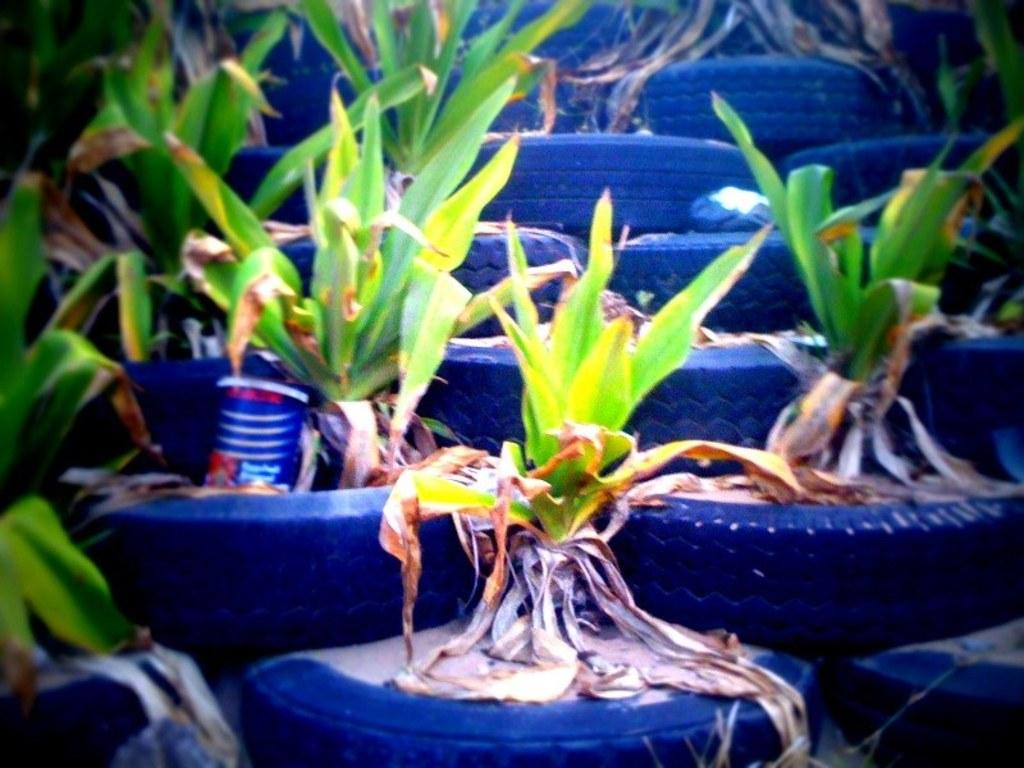What type of objects are being used to hold the plants in the image? The plants are in a tyre in the image. Can you describe the arrangement of the plants in the tyre? The plants are arranged within the circular shape of the tyre. Reasoning: Let' Let's think step by step in order to produce the conversation. We start by identifying the main subject in the image, which is the plants. Then, we focus on the unique aspect of the image, which is the use of a tyre to hold the plants. We formulate questions that focus on the arrangement and location of the plants, ensuring that each question can be answered definitively with the information given. Absurd Question/Answer: How many dogs are learning to play the guitar in the image? There are no dogs or guitars present in the image; it features plants in a tyre. 